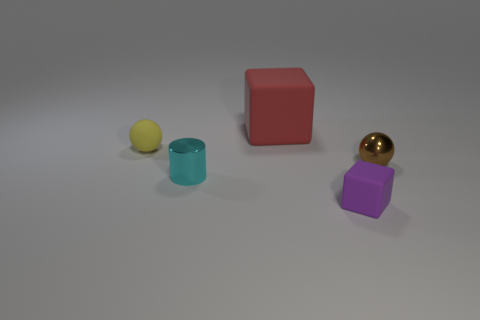How many blocks are small metallic things or red rubber things?
Provide a short and direct response. 1. There is a matte thing that is behind the tiny rubber object behind the small thing in front of the small metallic cylinder; what is its size?
Provide a short and direct response. Large. What color is the rubber object that is both on the right side of the tiny cyan metal object and behind the brown metal sphere?
Your answer should be compact. Red. Is the size of the yellow matte ball the same as the rubber object behind the small yellow rubber ball?
Your answer should be very brief. No. Is there anything else that is the same shape as the small cyan shiny thing?
Offer a very short reply. No. What color is the other metal thing that is the same shape as the yellow object?
Provide a succinct answer. Brown. Do the purple rubber block and the brown ball have the same size?
Your answer should be very brief. Yes. What number of other objects are the same size as the brown metal object?
Your answer should be compact. 3. How many objects are small rubber things in front of the tiny cyan metal cylinder or small objects that are to the left of the tiny brown metal ball?
Your response must be concise. 3. There is a yellow object that is the same size as the cylinder; what shape is it?
Provide a short and direct response. Sphere. 